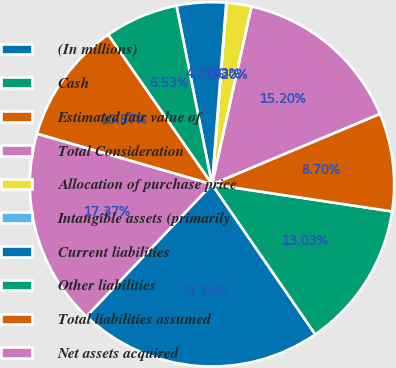<chart> <loc_0><loc_0><loc_500><loc_500><pie_chart><fcel>(In millions)<fcel>Cash<fcel>Estimated fair value of<fcel>Total Consideration<fcel>Allocation of purchase price<fcel>Intangible assets (primarily<fcel>Current liabilities<fcel>Other liabilities<fcel>Total liabilities assumed<fcel>Net assets acquired<nl><fcel>21.7%<fcel>13.03%<fcel>8.7%<fcel>15.2%<fcel>2.2%<fcel>0.03%<fcel>4.37%<fcel>6.53%<fcel>10.87%<fcel>17.37%<nl></chart> 